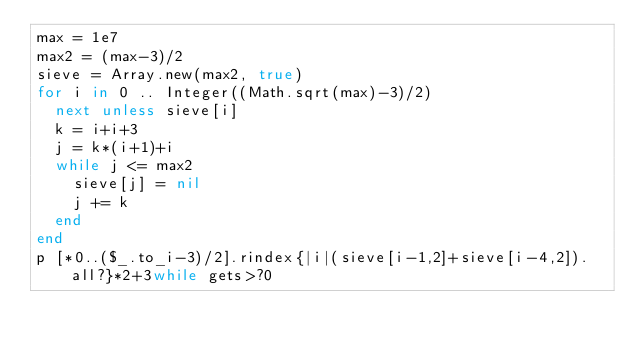Convert code to text. <code><loc_0><loc_0><loc_500><loc_500><_Ruby_>max = 1e7
max2 = (max-3)/2
sieve = Array.new(max2, true)
for i in 0 .. Integer((Math.sqrt(max)-3)/2)
  next unless sieve[i]
  k = i+i+3
  j = k*(i+1)+i
  while j <= max2
    sieve[j] = nil
    j += k
  end
end
p [*0..($_.to_i-3)/2].rindex{|i|(sieve[i-1,2]+sieve[i-4,2]).all?}*2+3while gets>?0</code> 